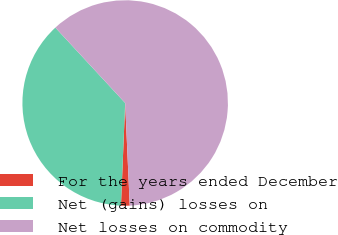Convert chart to OTSL. <chart><loc_0><loc_0><loc_500><loc_500><pie_chart><fcel>For the years ended December<fcel>Net (gains) losses on<fcel>Net losses on commodity<nl><fcel>1.36%<fcel>37.46%<fcel>61.18%<nl></chart> 